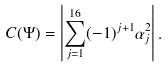<formula> <loc_0><loc_0><loc_500><loc_500>C ( \Psi ) = \left | \sum _ { j = 1 } ^ { 1 6 } ( - 1 ) ^ { j + 1 } \alpha ^ { 2 } _ { j } \right | .</formula> 